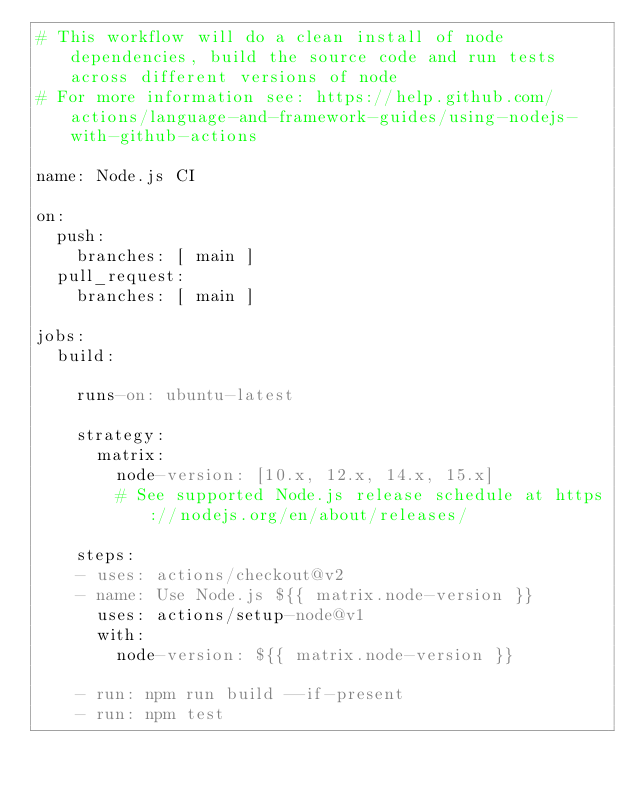<code> <loc_0><loc_0><loc_500><loc_500><_YAML_># This workflow will do a clean install of node dependencies, build the source code and run tests across different versions of node
# For more information see: https://help.github.com/actions/language-and-framework-guides/using-nodejs-with-github-actions

name: Node.js CI

on:
  push:
    branches: [ main ]
  pull_request:
    branches: [ main ]

jobs:
  build:

    runs-on: ubuntu-latest

    strategy:
      matrix:
        node-version: [10.x, 12.x, 14.x, 15.x]
        # See supported Node.js release schedule at https://nodejs.org/en/about/releases/

    steps:
    - uses: actions/checkout@v2
    - name: Use Node.js ${{ matrix.node-version }}
      uses: actions/setup-node@v1
      with:
        node-version: ${{ matrix.node-version }}

    - run: npm run build --if-present
    - run: npm test
</code> 